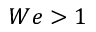<formula> <loc_0><loc_0><loc_500><loc_500>W e > 1</formula> 